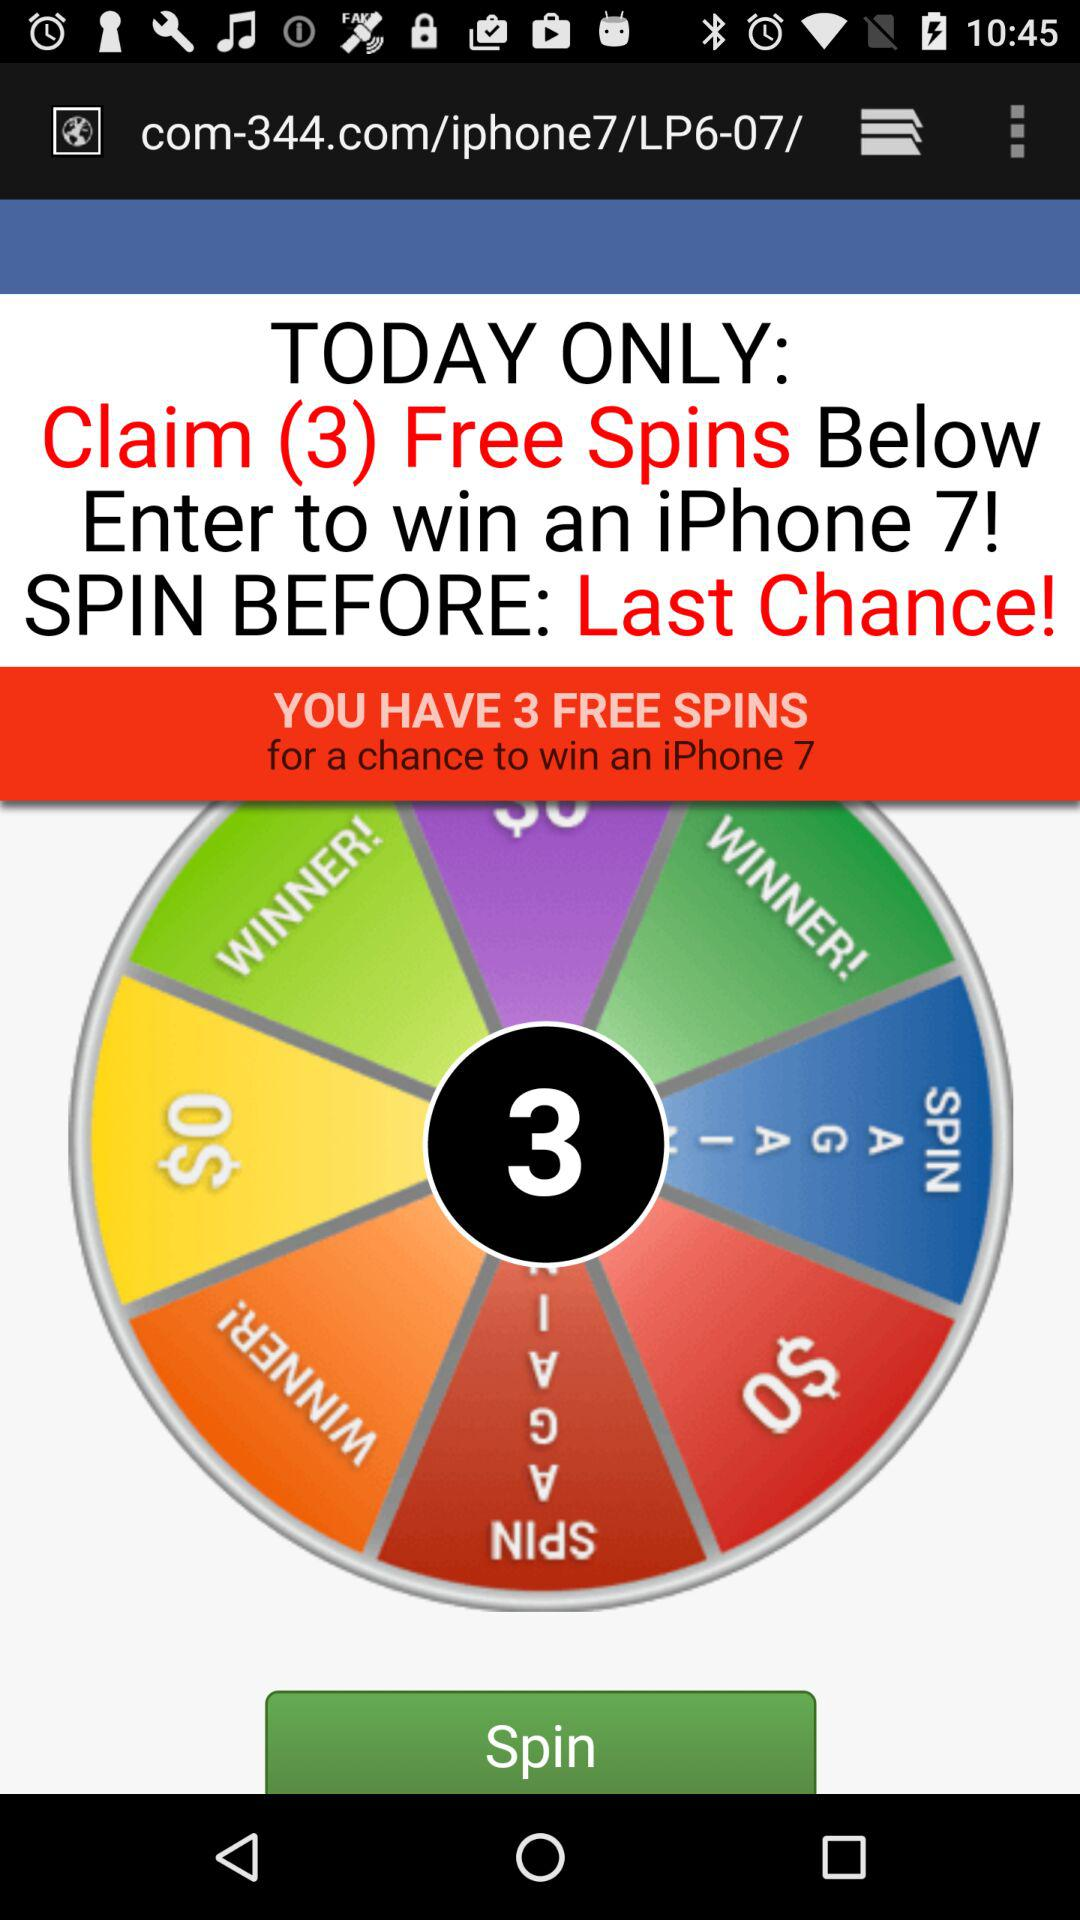For how long is the offer valid? The offer is valid for today only. 